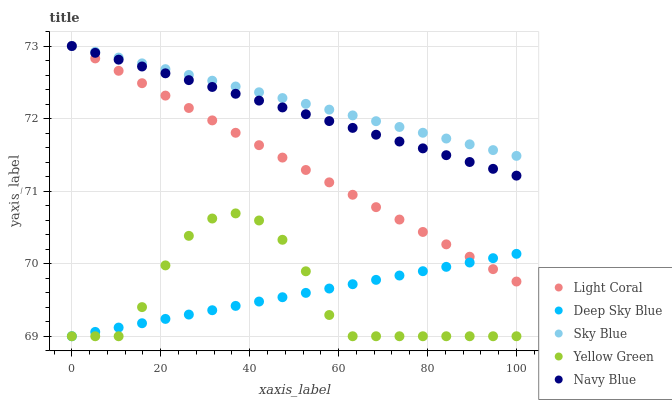Does Yellow Green have the minimum area under the curve?
Answer yes or no. Yes. Does Sky Blue have the maximum area under the curve?
Answer yes or no. Yes. Does Sky Blue have the minimum area under the curve?
Answer yes or no. No. Does Yellow Green have the maximum area under the curve?
Answer yes or no. No. Is Deep Sky Blue the smoothest?
Answer yes or no. Yes. Is Yellow Green the roughest?
Answer yes or no. Yes. Is Sky Blue the smoothest?
Answer yes or no. No. Is Sky Blue the roughest?
Answer yes or no. No. Does Yellow Green have the lowest value?
Answer yes or no. Yes. Does Sky Blue have the lowest value?
Answer yes or no. No. Does Navy Blue have the highest value?
Answer yes or no. Yes. Does Yellow Green have the highest value?
Answer yes or no. No. Is Yellow Green less than Light Coral?
Answer yes or no. Yes. Is Navy Blue greater than Deep Sky Blue?
Answer yes or no. Yes. Does Light Coral intersect Sky Blue?
Answer yes or no. Yes. Is Light Coral less than Sky Blue?
Answer yes or no. No. Is Light Coral greater than Sky Blue?
Answer yes or no. No. Does Yellow Green intersect Light Coral?
Answer yes or no. No. 